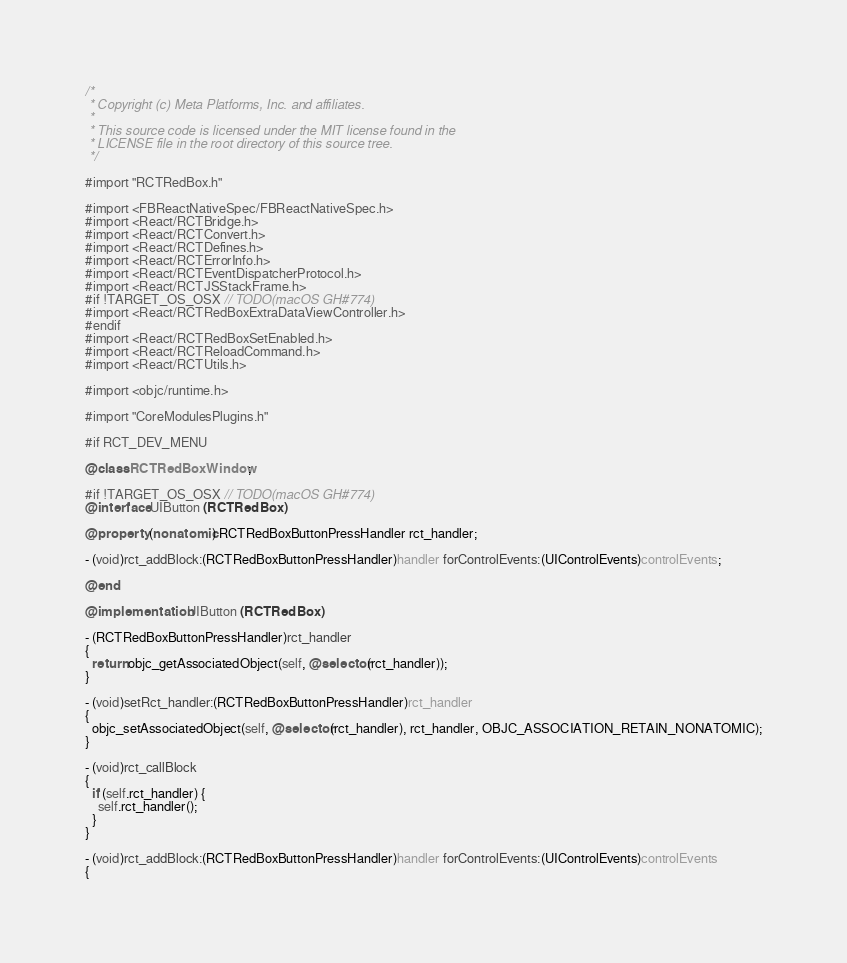Convert code to text. <code><loc_0><loc_0><loc_500><loc_500><_ObjectiveC_>/*
 * Copyright (c) Meta Platforms, Inc. and affiliates.
 *
 * This source code is licensed under the MIT license found in the
 * LICENSE file in the root directory of this source tree.
 */

#import "RCTRedBox.h"

#import <FBReactNativeSpec/FBReactNativeSpec.h>
#import <React/RCTBridge.h>
#import <React/RCTConvert.h>
#import <React/RCTDefines.h>
#import <React/RCTErrorInfo.h>
#import <React/RCTEventDispatcherProtocol.h>
#import <React/RCTJSStackFrame.h>
#if !TARGET_OS_OSX // TODO(macOS GH#774)
#import <React/RCTRedBoxExtraDataViewController.h>
#endif
#import <React/RCTRedBoxSetEnabled.h>
#import <React/RCTReloadCommand.h>
#import <React/RCTUtils.h>

#import <objc/runtime.h>

#import "CoreModulesPlugins.h"

#if RCT_DEV_MENU

@class RCTRedBoxWindow;

#if !TARGET_OS_OSX // TODO(macOS GH#774)
@interface UIButton (RCTRedBox)

@property (nonatomic) RCTRedBoxButtonPressHandler rct_handler;

- (void)rct_addBlock:(RCTRedBoxButtonPressHandler)handler forControlEvents:(UIControlEvents)controlEvents;

@end

@implementation UIButton (RCTRedBox)

- (RCTRedBoxButtonPressHandler)rct_handler
{
  return objc_getAssociatedObject(self, @selector(rct_handler));
}

- (void)setRct_handler:(RCTRedBoxButtonPressHandler)rct_handler
{
  objc_setAssociatedObject(self, @selector(rct_handler), rct_handler, OBJC_ASSOCIATION_RETAIN_NONATOMIC);
}

- (void)rct_callBlock
{
  if (self.rct_handler) {
    self.rct_handler();
  }
}

- (void)rct_addBlock:(RCTRedBoxButtonPressHandler)handler forControlEvents:(UIControlEvents)controlEvents
{</code> 